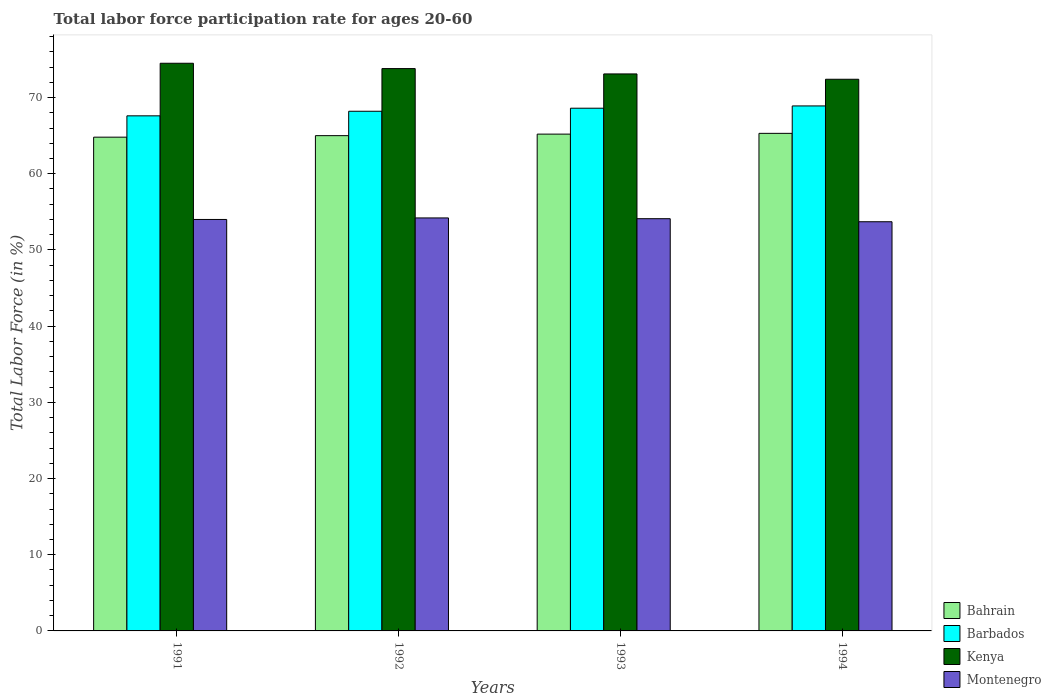How many groups of bars are there?
Your answer should be compact. 4. Are the number of bars per tick equal to the number of legend labels?
Offer a terse response. Yes. What is the label of the 2nd group of bars from the left?
Make the answer very short. 1992. In how many cases, is the number of bars for a given year not equal to the number of legend labels?
Your answer should be very brief. 0. What is the labor force participation rate in Barbados in 1993?
Give a very brief answer. 68.6. Across all years, what is the maximum labor force participation rate in Barbados?
Make the answer very short. 68.9. Across all years, what is the minimum labor force participation rate in Barbados?
Provide a succinct answer. 67.6. In which year was the labor force participation rate in Montenegro maximum?
Keep it short and to the point. 1992. In which year was the labor force participation rate in Bahrain minimum?
Your answer should be compact. 1991. What is the total labor force participation rate in Barbados in the graph?
Make the answer very short. 273.3. What is the difference between the labor force participation rate in Barbados in 1992 and that in 1994?
Provide a short and direct response. -0.7. What is the average labor force participation rate in Montenegro per year?
Make the answer very short. 54. In the year 1993, what is the difference between the labor force participation rate in Kenya and labor force participation rate in Bahrain?
Offer a very short reply. 7.9. What is the ratio of the labor force participation rate in Montenegro in 1991 to that in 1994?
Give a very brief answer. 1.01. What is the difference between the highest and the second highest labor force participation rate in Kenya?
Offer a terse response. 0.7. What is the difference between the highest and the lowest labor force participation rate in Kenya?
Offer a very short reply. 2.1. Is it the case that in every year, the sum of the labor force participation rate in Bahrain and labor force participation rate in Barbados is greater than the sum of labor force participation rate in Montenegro and labor force participation rate in Kenya?
Your response must be concise. Yes. What does the 1st bar from the left in 1993 represents?
Your response must be concise. Bahrain. What does the 4th bar from the right in 1991 represents?
Provide a succinct answer. Bahrain. Is it the case that in every year, the sum of the labor force participation rate in Bahrain and labor force participation rate in Kenya is greater than the labor force participation rate in Barbados?
Ensure brevity in your answer.  Yes. How many bars are there?
Ensure brevity in your answer.  16. How many years are there in the graph?
Offer a very short reply. 4. Does the graph contain any zero values?
Your response must be concise. No. Does the graph contain grids?
Provide a succinct answer. No. Where does the legend appear in the graph?
Your response must be concise. Bottom right. What is the title of the graph?
Make the answer very short. Total labor force participation rate for ages 20-60. What is the label or title of the X-axis?
Your response must be concise. Years. What is the Total Labor Force (in %) in Bahrain in 1991?
Ensure brevity in your answer.  64.8. What is the Total Labor Force (in %) of Barbados in 1991?
Keep it short and to the point. 67.6. What is the Total Labor Force (in %) of Kenya in 1991?
Give a very brief answer. 74.5. What is the Total Labor Force (in %) of Montenegro in 1991?
Your response must be concise. 54. What is the Total Labor Force (in %) in Barbados in 1992?
Your answer should be very brief. 68.2. What is the Total Labor Force (in %) of Kenya in 1992?
Provide a succinct answer. 73.8. What is the Total Labor Force (in %) in Montenegro in 1992?
Provide a succinct answer. 54.2. What is the Total Labor Force (in %) of Bahrain in 1993?
Offer a very short reply. 65.2. What is the Total Labor Force (in %) of Barbados in 1993?
Give a very brief answer. 68.6. What is the Total Labor Force (in %) of Kenya in 1993?
Make the answer very short. 73.1. What is the Total Labor Force (in %) of Montenegro in 1993?
Provide a short and direct response. 54.1. What is the Total Labor Force (in %) in Bahrain in 1994?
Offer a terse response. 65.3. What is the Total Labor Force (in %) in Barbados in 1994?
Your response must be concise. 68.9. What is the Total Labor Force (in %) of Kenya in 1994?
Give a very brief answer. 72.4. What is the Total Labor Force (in %) in Montenegro in 1994?
Offer a terse response. 53.7. Across all years, what is the maximum Total Labor Force (in %) in Bahrain?
Offer a very short reply. 65.3. Across all years, what is the maximum Total Labor Force (in %) of Barbados?
Provide a succinct answer. 68.9. Across all years, what is the maximum Total Labor Force (in %) in Kenya?
Provide a succinct answer. 74.5. Across all years, what is the maximum Total Labor Force (in %) in Montenegro?
Make the answer very short. 54.2. Across all years, what is the minimum Total Labor Force (in %) of Bahrain?
Make the answer very short. 64.8. Across all years, what is the minimum Total Labor Force (in %) in Barbados?
Give a very brief answer. 67.6. Across all years, what is the minimum Total Labor Force (in %) in Kenya?
Offer a very short reply. 72.4. Across all years, what is the minimum Total Labor Force (in %) of Montenegro?
Provide a short and direct response. 53.7. What is the total Total Labor Force (in %) of Bahrain in the graph?
Offer a very short reply. 260.3. What is the total Total Labor Force (in %) of Barbados in the graph?
Your answer should be very brief. 273.3. What is the total Total Labor Force (in %) of Kenya in the graph?
Offer a very short reply. 293.8. What is the total Total Labor Force (in %) of Montenegro in the graph?
Your answer should be very brief. 216. What is the difference between the Total Labor Force (in %) of Bahrain in 1991 and that in 1992?
Ensure brevity in your answer.  -0.2. What is the difference between the Total Labor Force (in %) in Kenya in 1991 and that in 1994?
Your answer should be very brief. 2.1. What is the difference between the Total Labor Force (in %) in Bahrain in 1992 and that in 1993?
Give a very brief answer. -0.2. What is the difference between the Total Labor Force (in %) of Montenegro in 1992 and that in 1993?
Make the answer very short. 0.1. What is the difference between the Total Labor Force (in %) in Barbados in 1992 and that in 1994?
Provide a short and direct response. -0.7. What is the difference between the Total Labor Force (in %) in Barbados in 1993 and that in 1994?
Make the answer very short. -0.3. What is the difference between the Total Labor Force (in %) in Kenya in 1993 and that in 1994?
Your answer should be very brief. 0.7. What is the difference between the Total Labor Force (in %) in Montenegro in 1993 and that in 1994?
Your response must be concise. 0.4. What is the difference between the Total Labor Force (in %) of Barbados in 1991 and the Total Labor Force (in %) of Montenegro in 1992?
Make the answer very short. 13.4. What is the difference between the Total Labor Force (in %) of Kenya in 1991 and the Total Labor Force (in %) of Montenegro in 1992?
Your answer should be compact. 20.3. What is the difference between the Total Labor Force (in %) of Bahrain in 1991 and the Total Labor Force (in %) of Barbados in 1993?
Offer a terse response. -3.8. What is the difference between the Total Labor Force (in %) of Bahrain in 1991 and the Total Labor Force (in %) of Kenya in 1993?
Offer a very short reply. -8.3. What is the difference between the Total Labor Force (in %) of Bahrain in 1991 and the Total Labor Force (in %) of Montenegro in 1993?
Give a very brief answer. 10.7. What is the difference between the Total Labor Force (in %) in Barbados in 1991 and the Total Labor Force (in %) in Montenegro in 1993?
Offer a terse response. 13.5. What is the difference between the Total Labor Force (in %) of Kenya in 1991 and the Total Labor Force (in %) of Montenegro in 1993?
Keep it short and to the point. 20.4. What is the difference between the Total Labor Force (in %) in Barbados in 1991 and the Total Labor Force (in %) in Kenya in 1994?
Provide a succinct answer. -4.8. What is the difference between the Total Labor Force (in %) in Barbados in 1991 and the Total Labor Force (in %) in Montenegro in 1994?
Provide a short and direct response. 13.9. What is the difference between the Total Labor Force (in %) of Kenya in 1991 and the Total Labor Force (in %) of Montenegro in 1994?
Provide a short and direct response. 20.8. What is the difference between the Total Labor Force (in %) of Bahrain in 1992 and the Total Labor Force (in %) of Barbados in 1993?
Keep it short and to the point. -3.6. What is the difference between the Total Labor Force (in %) in Bahrain in 1992 and the Total Labor Force (in %) in Kenya in 1993?
Provide a succinct answer. -8.1. What is the difference between the Total Labor Force (in %) of Barbados in 1992 and the Total Labor Force (in %) of Kenya in 1993?
Your response must be concise. -4.9. What is the difference between the Total Labor Force (in %) in Barbados in 1992 and the Total Labor Force (in %) in Montenegro in 1993?
Ensure brevity in your answer.  14.1. What is the difference between the Total Labor Force (in %) in Bahrain in 1992 and the Total Labor Force (in %) in Kenya in 1994?
Your answer should be compact. -7.4. What is the difference between the Total Labor Force (in %) of Bahrain in 1992 and the Total Labor Force (in %) of Montenegro in 1994?
Provide a short and direct response. 11.3. What is the difference between the Total Labor Force (in %) of Barbados in 1992 and the Total Labor Force (in %) of Montenegro in 1994?
Offer a very short reply. 14.5. What is the difference between the Total Labor Force (in %) in Kenya in 1992 and the Total Labor Force (in %) in Montenegro in 1994?
Provide a short and direct response. 20.1. What is the difference between the Total Labor Force (in %) of Bahrain in 1993 and the Total Labor Force (in %) of Barbados in 1994?
Your answer should be very brief. -3.7. What is the difference between the Total Labor Force (in %) in Barbados in 1993 and the Total Labor Force (in %) in Kenya in 1994?
Your response must be concise. -3.8. What is the difference between the Total Labor Force (in %) in Barbados in 1993 and the Total Labor Force (in %) in Montenegro in 1994?
Ensure brevity in your answer.  14.9. What is the difference between the Total Labor Force (in %) in Kenya in 1993 and the Total Labor Force (in %) in Montenegro in 1994?
Your answer should be very brief. 19.4. What is the average Total Labor Force (in %) in Bahrain per year?
Offer a terse response. 65.08. What is the average Total Labor Force (in %) in Barbados per year?
Make the answer very short. 68.33. What is the average Total Labor Force (in %) of Kenya per year?
Your answer should be compact. 73.45. In the year 1991, what is the difference between the Total Labor Force (in %) in Bahrain and Total Labor Force (in %) in Barbados?
Provide a short and direct response. -2.8. In the year 1991, what is the difference between the Total Labor Force (in %) in Bahrain and Total Labor Force (in %) in Montenegro?
Your response must be concise. 10.8. In the year 1991, what is the difference between the Total Labor Force (in %) of Barbados and Total Labor Force (in %) of Kenya?
Keep it short and to the point. -6.9. In the year 1991, what is the difference between the Total Labor Force (in %) in Kenya and Total Labor Force (in %) in Montenegro?
Provide a succinct answer. 20.5. In the year 1992, what is the difference between the Total Labor Force (in %) of Bahrain and Total Labor Force (in %) of Kenya?
Make the answer very short. -8.8. In the year 1992, what is the difference between the Total Labor Force (in %) in Bahrain and Total Labor Force (in %) in Montenegro?
Make the answer very short. 10.8. In the year 1992, what is the difference between the Total Labor Force (in %) in Barbados and Total Labor Force (in %) in Montenegro?
Offer a terse response. 14. In the year 1992, what is the difference between the Total Labor Force (in %) of Kenya and Total Labor Force (in %) of Montenegro?
Provide a short and direct response. 19.6. In the year 1993, what is the difference between the Total Labor Force (in %) of Bahrain and Total Labor Force (in %) of Barbados?
Your answer should be compact. -3.4. In the year 1993, what is the difference between the Total Labor Force (in %) of Bahrain and Total Labor Force (in %) of Montenegro?
Offer a terse response. 11.1. In the year 1994, what is the difference between the Total Labor Force (in %) of Bahrain and Total Labor Force (in %) of Barbados?
Make the answer very short. -3.6. In the year 1994, what is the difference between the Total Labor Force (in %) of Kenya and Total Labor Force (in %) of Montenegro?
Your answer should be very brief. 18.7. What is the ratio of the Total Labor Force (in %) in Bahrain in 1991 to that in 1992?
Make the answer very short. 1. What is the ratio of the Total Labor Force (in %) of Barbados in 1991 to that in 1992?
Your answer should be compact. 0.99. What is the ratio of the Total Labor Force (in %) of Kenya in 1991 to that in 1992?
Make the answer very short. 1.01. What is the ratio of the Total Labor Force (in %) in Barbados in 1991 to that in 1993?
Provide a succinct answer. 0.99. What is the ratio of the Total Labor Force (in %) of Kenya in 1991 to that in 1993?
Offer a terse response. 1.02. What is the ratio of the Total Labor Force (in %) in Montenegro in 1991 to that in 1993?
Your response must be concise. 1. What is the ratio of the Total Labor Force (in %) in Barbados in 1991 to that in 1994?
Your answer should be compact. 0.98. What is the ratio of the Total Labor Force (in %) in Montenegro in 1991 to that in 1994?
Your response must be concise. 1.01. What is the ratio of the Total Labor Force (in %) in Barbados in 1992 to that in 1993?
Your answer should be very brief. 0.99. What is the ratio of the Total Labor Force (in %) in Kenya in 1992 to that in 1993?
Offer a very short reply. 1.01. What is the ratio of the Total Labor Force (in %) in Barbados in 1992 to that in 1994?
Make the answer very short. 0.99. What is the ratio of the Total Labor Force (in %) in Kenya in 1992 to that in 1994?
Provide a short and direct response. 1.02. What is the ratio of the Total Labor Force (in %) of Montenegro in 1992 to that in 1994?
Keep it short and to the point. 1.01. What is the ratio of the Total Labor Force (in %) in Kenya in 1993 to that in 1994?
Make the answer very short. 1.01. What is the ratio of the Total Labor Force (in %) in Montenegro in 1993 to that in 1994?
Offer a terse response. 1.01. What is the difference between the highest and the second highest Total Labor Force (in %) in Bahrain?
Your answer should be compact. 0.1. What is the difference between the highest and the second highest Total Labor Force (in %) of Barbados?
Your response must be concise. 0.3. What is the difference between the highest and the lowest Total Labor Force (in %) in Barbados?
Your answer should be very brief. 1.3. What is the difference between the highest and the lowest Total Labor Force (in %) of Montenegro?
Your response must be concise. 0.5. 